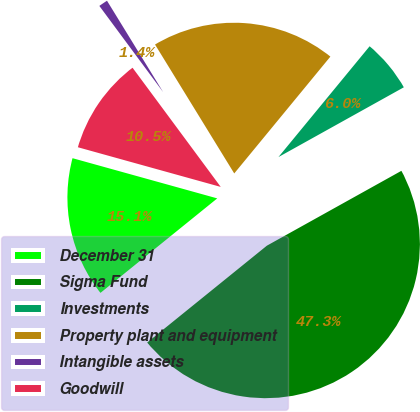<chart> <loc_0><loc_0><loc_500><loc_500><pie_chart><fcel>December 31<fcel>Sigma Fund<fcel>Investments<fcel>Property plant and equipment<fcel>Intangible assets<fcel>Goodwill<nl><fcel>15.14%<fcel>47.26%<fcel>5.96%<fcel>19.73%<fcel>1.37%<fcel>10.55%<nl></chart> 